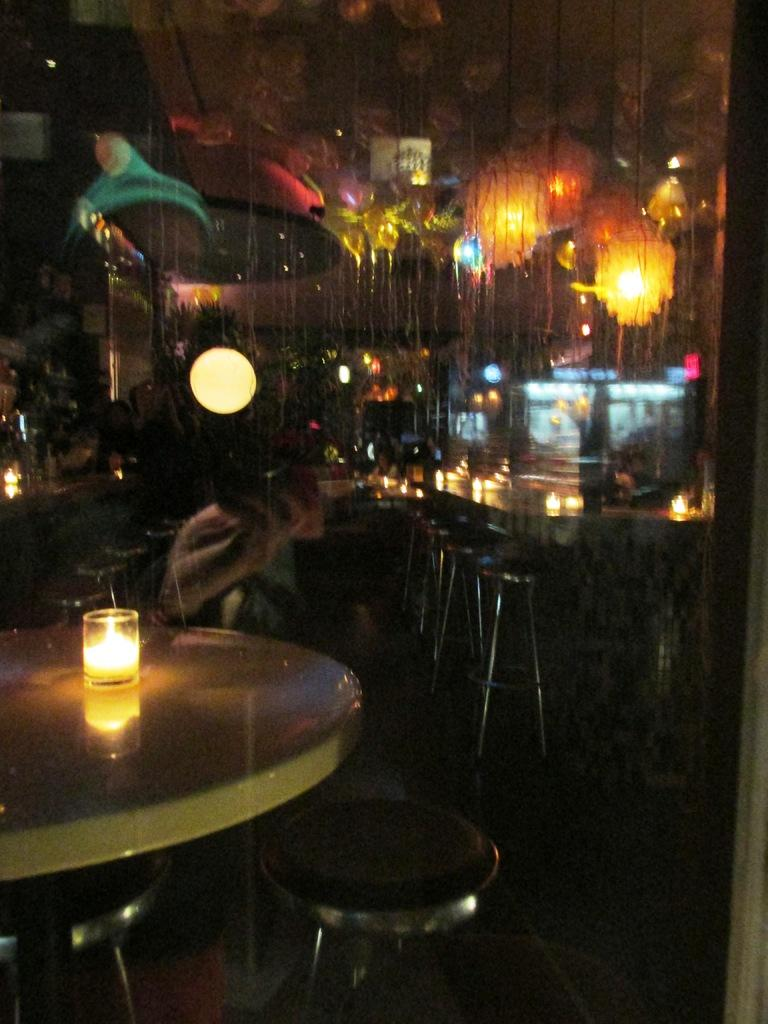What object is placed inside a glass in the image? There is a candle in a glass in the image. What type of furniture is present in the image? There are chairs and tables in the image. What provides illumination in the image? There are lights visible in the image. What type of instrument is being played in the image? There is no instrument being played in the image. What type of lace can be seen on the chairs in the image? There is no lace visible on the chairs in the image. 